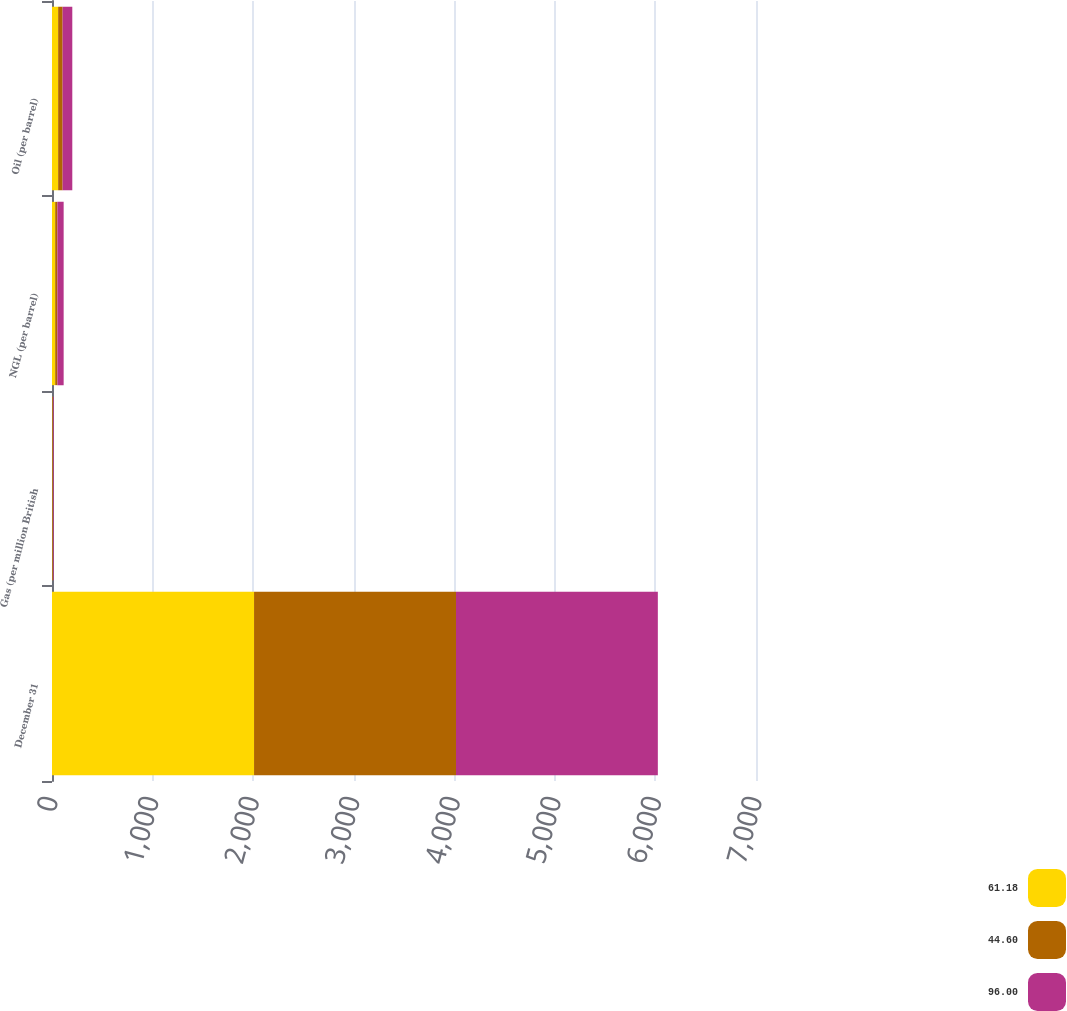Convert chart to OTSL. <chart><loc_0><loc_0><loc_500><loc_500><stacked_bar_chart><ecel><fcel>December 31<fcel>Gas (per million British<fcel>NGL (per barrel)<fcel>Oil (per barrel)<nl><fcel>61.18<fcel>2009<fcel>3.87<fcel>31.73<fcel>61.18<nl><fcel>44.6<fcel>2008<fcel>5.71<fcel>22<fcel>44.6<nl><fcel>96<fcel>2007<fcel>6.8<fcel>62.16<fcel>96<nl></chart> 